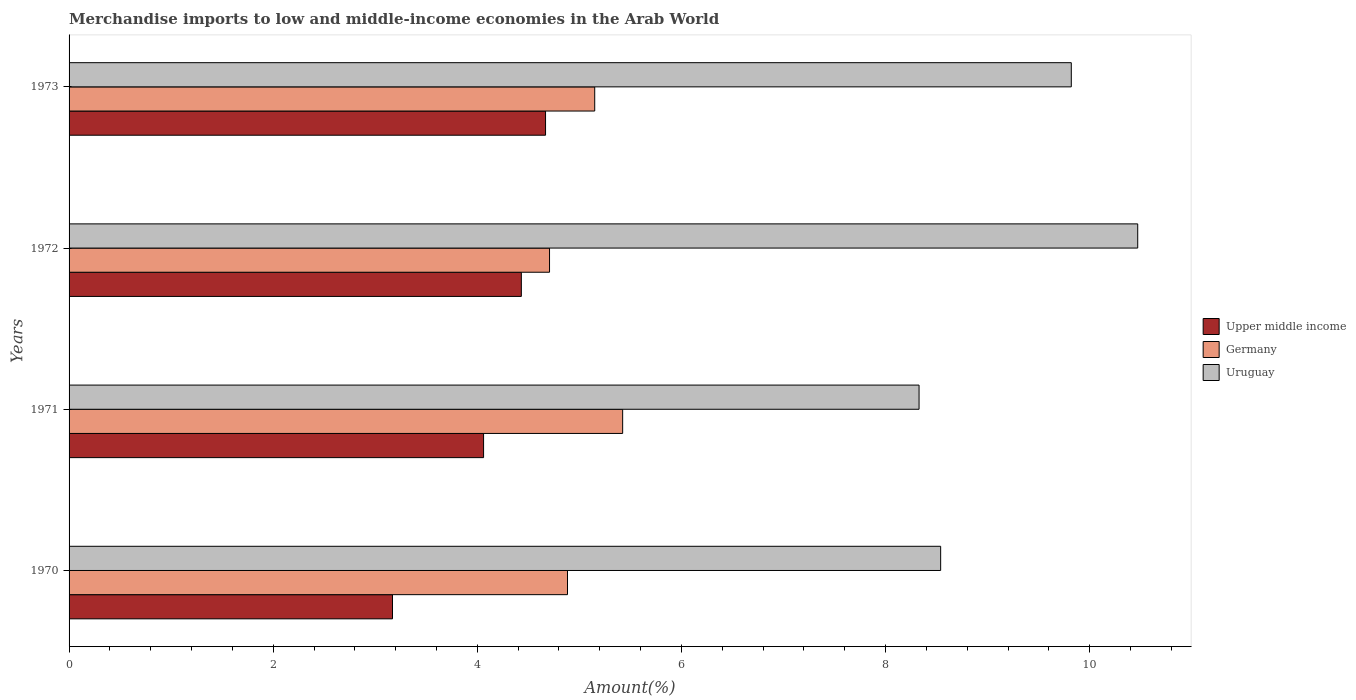How many groups of bars are there?
Keep it short and to the point. 4. How many bars are there on the 1st tick from the top?
Give a very brief answer. 3. What is the percentage of amount earned from merchandise imports in Germany in 1973?
Offer a terse response. 5.15. Across all years, what is the maximum percentage of amount earned from merchandise imports in Upper middle income?
Your answer should be compact. 4.67. Across all years, what is the minimum percentage of amount earned from merchandise imports in Uruguay?
Your answer should be compact. 8.33. In which year was the percentage of amount earned from merchandise imports in Upper middle income maximum?
Your response must be concise. 1973. What is the total percentage of amount earned from merchandise imports in Germany in the graph?
Offer a very short reply. 20.17. What is the difference between the percentage of amount earned from merchandise imports in Germany in 1971 and that in 1972?
Offer a terse response. 0.72. What is the difference between the percentage of amount earned from merchandise imports in Germany in 1973 and the percentage of amount earned from merchandise imports in Uruguay in 1972?
Give a very brief answer. -5.32. What is the average percentage of amount earned from merchandise imports in Upper middle income per year?
Your response must be concise. 4.08. In the year 1971, what is the difference between the percentage of amount earned from merchandise imports in Uruguay and percentage of amount earned from merchandise imports in Upper middle income?
Provide a succinct answer. 4.27. What is the ratio of the percentage of amount earned from merchandise imports in Upper middle income in 1971 to that in 1973?
Provide a short and direct response. 0.87. What is the difference between the highest and the second highest percentage of amount earned from merchandise imports in Uruguay?
Your response must be concise. 0.65. What is the difference between the highest and the lowest percentage of amount earned from merchandise imports in Uruguay?
Ensure brevity in your answer.  2.14. Is the sum of the percentage of amount earned from merchandise imports in Upper middle income in 1971 and 1972 greater than the maximum percentage of amount earned from merchandise imports in Uruguay across all years?
Make the answer very short. No. What does the 1st bar from the bottom in 1973 represents?
Provide a short and direct response. Upper middle income. How many bars are there?
Offer a very short reply. 12. How many years are there in the graph?
Your answer should be very brief. 4. Are the values on the major ticks of X-axis written in scientific E-notation?
Your answer should be compact. No. Does the graph contain grids?
Give a very brief answer. No. Where does the legend appear in the graph?
Keep it short and to the point. Center right. How many legend labels are there?
Keep it short and to the point. 3. What is the title of the graph?
Keep it short and to the point. Merchandise imports to low and middle-income economies in the Arab World. What is the label or title of the X-axis?
Ensure brevity in your answer.  Amount(%). What is the label or title of the Y-axis?
Your answer should be compact. Years. What is the Amount(%) of Upper middle income in 1970?
Offer a terse response. 3.17. What is the Amount(%) of Germany in 1970?
Your answer should be compact. 4.88. What is the Amount(%) in Uruguay in 1970?
Offer a terse response. 8.54. What is the Amount(%) in Upper middle income in 1971?
Your response must be concise. 4.06. What is the Amount(%) in Germany in 1971?
Give a very brief answer. 5.42. What is the Amount(%) in Uruguay in 1971?
Keep it short and to the point. 8.33. What is the Amount(%) of Upper middle income in 1972?
Give a very brief answer. 4.43. What is the Amount(%) in Germany in 1972?
Offer a very short reply. 4.71. What is the Amount(%) in Uruguay in 1972?
Ensure brevity in your answer.  10.47. What is the Amount(%) of Upper middle income in 1973?
Give a very brief answer. 4.67. What is the Amount(%) in Germany in 1973?
Keep it short and to the point. 5.15. What is the Amount(%) in Uruguay in 1973?
Offer a terse response. 9.82. Across all years, what is the maximum Amount(%) in Upper middle income?
Provide a succinct answer. 4.67. Across all years, what is the maximum Amount(%) of Germany?
Provide a short and direct response. 5.42. Across all years, what is the maximum Amount(%) of Uruguay?
Ensure brevity in your answer.  10.47. Across all years, what is the minimum Amount(%) of Upper middle income?
Make the answer very short. 3.17. Across all years, what is the minimum Amount(%) of Germany?
Your answer should be compact. 4.71. Across all years, what is the minimum Amount(%) of Uruguay?
Your response must be concise. 8.33. What is the total Amount(%) of Upper middle income in the graph?
Keep it short and to the point. 16.33. What is the total Amount(%) of Germany in the graph?
Offer a terse response. 20.17. What is the total Amount(%) of Uruguay in the graph?
Provide a succinct answer. 37.16. What is the difference between the Amount(%) of Upper middle income in 1970 and that in 1971?
Your answer should be very brief. -0.89. What is the difference between the Amount(%) of Germany in 1970 and that in 1971?
Offer a very short reply. -0.54. What is the difference between the Amount(%) of Uruguay in 1970 and that in 1971?
Your answer should be compact. 0.21. What is the difference between the Amount(%) of Upper middle income in 1970 and that in 1972?
Give a very brief answer. -1.26. What is the difference between the Amount(%) of Germany in 1970 and that in 1972?
Your response must be concise. 0.18. What is the difference between the Amount(%) in Uruguay in 1970 and that in 1972?
Provide a short and direct response. -1.93. What is the difference between the Amount(%) in Upper middle income in 1970 and that in 1973?
Make the answer very short. -1.5. What is the difference between the Amount(%) of Germany in 1970 and that in 1973?
Offer a very short reply. -0.27. What is the difference between the Amount(%) of Uruguay in 1970 and that in 1973?
Your response must be concise. -1.28. What is the difference between the Amount(%) in Upper middle income in 1971 and that in 1972?
Make the answer very short. -0.37. What is the difference between the Amount(%) in Germany in 1971 and that in 1972?
Make the answer very short. 0.72. What is the difference between the Amount(%) of Uruguay in 1971 and that in 1972?
Make the answer very short. -2.14. What is the difference between the Amount(%) in Upper middle income in 1971 and that in 1973?
Your answer should be compact. -0.61. What is the difference between the Amount(%) in Germany in 1971 and that in 1973?
Provide a succinct answer. 0.27. What is the difference between the Amount(%) in Uruguay in 1971 and that in 1973?
Give a very brief answer. -1.49. What is the difference between the Amount(%) of Upper middle income in 1972 and that in 1973?
Your response must be concise. -0.24. What is the difference between the Amount(%) of Germany in 1972 and that in 1973?
Make the answer very short. -0.44. What is the difference between the Amount(%) of Uruguay in 1972 and that in 1973?
Offer a very short reply. 0.65. What is the difference between the Amount(%) in Upper middle income in 1970 and the Amount(%) in Germany in 1971?
Your answer should be very brief. -2.26. What is the difference between the Amount(%) of Upper middle income in 1970 and the Amount(%) of Uruguay in 1971?
Your answer should be very brief. -5.16. What is the difference between the Amount(%) in Germany in 1970 and the Amount(%) in Uruguay in 1971?
Provide a short and direct response. -3.44. What is the difference between the Amount(%) of Upper middle income in 1970 and the Amount(%) of Germany in 1972?
Your answer should be compact. -1.54. What is the difference between the Amount(%) of Upper middle income in 1970 and the Amount(%) of Uruguay in 1972?
Make the answer very short. -7.3. What is the difference between the Amount(%) of Germany in 1970 and the Amount(%) of Uruguay in 1972?
Your response must be concise. -5.59. What is the difference between the Amount(%) in Upper middle income in 1970 and the Amount(%) in Germany in 1973?
Your answer should be very brief. -1.98. What is the difference between the Amount(%) in Upper middle income in 1970 and the Amount(%) in Uruguay in 1973?
Ensure brevity in your answer.  -6.65. What is the difference between the Amount(%) of Germany in 1970 and the Amount(%) of Uruguay in 1973?
Offer a very short reply. -4.94. What is the difference between the Amount(%) of Upper middle income in 1971 and the Amount(%) of Germany in 1972?
Offer a very short reply. -0.65. What is the difference between the Amount(%) of Upper middle income in 1971 and the Amount(%) of Uruguay in 1972?
Provide a short and direct response. -6.41. What is the difference between the Amount(%) in Germany in 1971 and the Amount(%) in Uruguay in 1972?
Ensure brevity in your answer.  -5.05. What is the difference between the Amount(%) in Upper middle income in 1971 and the Amount(%) in Germany in 1973?
Ensure brevity in your answer.  -1.09. What is the difference between the Amount(%) in Upper middle income in 1971 and the Amount(%) in Uruguay in 1973?
Make the answer very short. -5.76. What is the difference between the Amount(%) in Germany in 1971 and the Amount(%) in Uruguay in 1973?
Your answer should be very brief. -4.4. What is the difference between the Amount(%) in Upper middle income in 1972 and the Amount(%) in Germany in 1973?
Make the answer very short. -0.72. What is the difference between the Amount(%) of Upper middle income in 1972 and the Amount(%) of Uruguay in 1973?
Your answer should be very brief. -5.39. What is the difference between the Amount(%) in Germany in 1972 and the Amount(%) in Uruguay in 1973?
Offer a very short reply. -5.11. What is the average Amount(%) in Upper middle income per year?
Your answer should be very brief. 4.08. What is the average Amount(%) in Germany per year?
Provide a succinct answer. 5.04. What is the average Amount(%) of Uruguay per year?
Your answer should be very brief. 9.29. In the year 1970, what is the difference between the Amount(%) of Upper middle income and Amount(%) of Germany?
Your answer should be very brief. -1.71. In the year 1970, what is the difference between the Amount(%) in Upper middle income and Amount(%) in Uruguay?
Offer a very short reply. -5.37. In the year 1970, what is the difference between the Amount(%) in Germany and Amount(%) in Uruguay?
Ensure brevity in your answer.  -3.66. In the year 1971, what is the difference between the Amount(%) of Upper middle income and Amount(%) of Germany?
Ensure brevity in your answer.  -1.36. In the year 1971, what is the difference between the Amount(%) in Upper middle income and Amount(%) in Uruguay?
Keep it short and to the point. -4.27. In the year 1971, what is the difference between the Amount(%) in Germany and Amount(%) in Uruguay?
Your response must be concise. -2.9. In the year 1972, what is the difference between the Amount(%) in Upper middle income and Amount(%) in Germany?
Provide a short and direct response. -0.28. In the year 1972, what is the difference between the Amount(%) in Upper middle income and Amount(%) in Uruguay?
Give a very brief answer. -6.04. In the year 1972, what is the difference between the Amount(%) of Germany and Amount(%) of Uruguay?
Your answer should be compact. -5.76. In the year 1973, what is the difference between the Amount(%) of Upper middle income and Amount(%) of Germany?
Offer a very short reply. -0.48. In the year 1973, what is the difference between the Amount(%) in Upper middle income and Amount(%) in Uruguay?
Keep it short and to the point. -5.15. In the year 1973, what is the difference between the Amount(%) of Germany and Amount(%) of Uruguay?
Your answer should be very brief. -4.67. What is the ratio of the Amount(%) in Upper middle income in 1970 to that in 1971?
Offer a very short reply. 0.78. What is the ratio of the Amount(%) in Germany in 1970 to that in 1971?
Offer a terse response. 0.9. What is the ratio of the Amount(%) of Uruguay in 1970 to that in 1971?
Provide a succinct answer. 1.03. What is the ratio of the Amount(%) in Upper middle income in 1970 to that in 1972?
Give a very brief answer. 0.72. What is the ratio of the Amount(%) in Germany in 1970 to that in 1972?
Make the answer very short. 1.04. What is the ratio of the Amount(%) in Uruguay in 1970 to that in 1972?
Offer a terse response. 0.82. What is the ratio of the Amount(%) of Upper middle income in 1970 to that in 1973?
Offer a very short reply. 0.68. What is the ratio of the Amount(%) of Germany in 1970 to that in 1973?
Keep it short and to the point. 0.95. What is the ratio of the Amount(%) of Uruguay in 1970 to that in 1973?
Your answer should be very brief. 0.87. What is the ratio of the Amount(%) in Upper middle income in 1971 to that in 1972?
Offer a terse response. 0.92. What is the ratio of the Amount(%) in Germany in 1971 to that in 1972?
Make the answer very short. 1.15. What is the ratio of the Amount(%) in Uruguay in 1971 to that in 1972?
Your response must be concise. 0.8. What is the ratio of the Amount(%) of Upper middle income in 1971 to that in 1973?
Offer a very short reply. 0.87. What is the ratio of the Amount(%) of Germany in 1971 to that in 1973?
Your answer should be compact. 1.05. What is the ratio of the Amount(%) in Uruguay in 1971 to that in 1973?
Keep it short and to the point. 0.85. What is the ratio of the Amount(%) of Upper middle income in 1972 to that in 1973?
Provide a short and direct response. 0.95. What is the ratio of the Amount(%) of Germany in 1972 to that in 1973?
Keep it short and to the point. 0.91. What is the ratio of the Amount(%) in Uruguay in 1972 to that in 1973?
Provide a succinct answer. 1.07. What is the difference between the highest and the second highest Amount(%) in Upper middle income?
Keep it short and to the point. 0.24. What is the difference between the highest and the second highest Amount(%) in Germany?
Your answer should be very brief. 0.27. What is the difference between the highest and the second highest Amount(%) in Uruguay?
Ensure brevity in your answer.  0.65. What is the difference between the highest and the lowest Amount(%) in Upper middle income?
Offer a terse response. 1.5. What is the difference between the highest and the lowest Amount(%) in Germany?
Ensure brevity in your answer.  0.72. What is the difference between the highest and the lowest Amount(%) of Uruguay?
Keep it short and to the point. 2.14. 